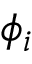Convert formula to latex. <formula><loc_0><loc_0><loc_500><loc_500>\phi _ { i }</formula> 